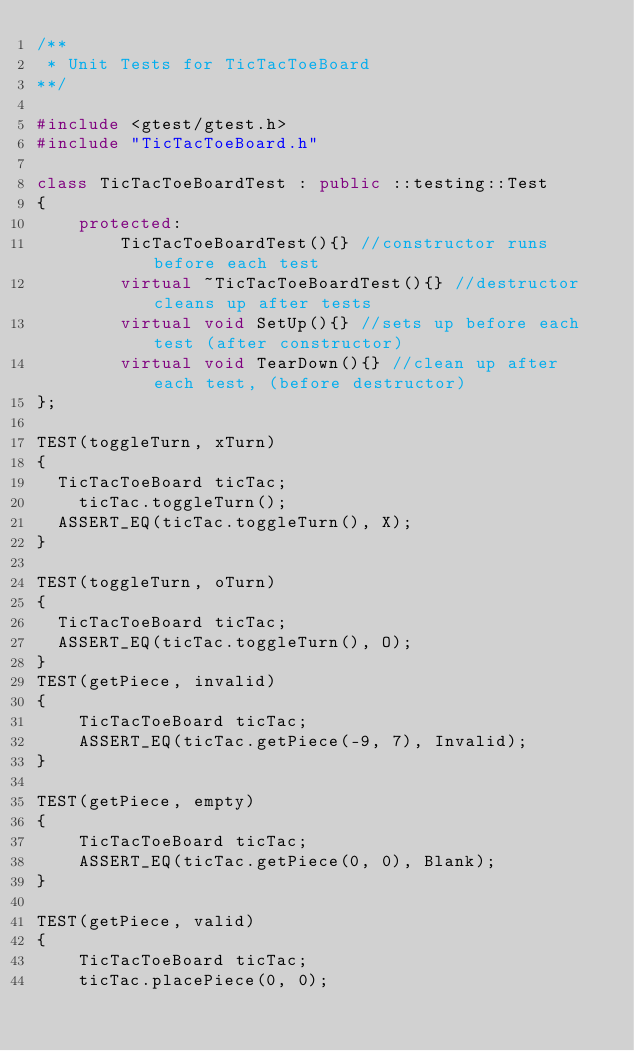<code> <loc_0><loc_0><loc_500><loc_500><_C++_>/**
 * Unit Tests for TicTacToeBoard
**/

#include <gtest/gtest.h>
#include "TicTacToeBoard.h"

class TicTacToeBoardTest : public ::testing::Test
{
	protected:
		TicTacToeBoardTest(){} //constructor runs before each test
		virtual ~TicTacToeBoardTest(){} //destructor cleans up after tests
		virtual void SetUp(){} //sets up before each test (after constructor)
		virtual void TearDown(){} //clean up after each test, (before destructor)
};

TEST(toggleTurn, xTurn)
{
  TicTacToeBoard ticTac;
	ticTac.toggleTurn();
  ASSERT_EQ(ticTac.toggleTurn(), X);
}

TEST(toggleTurn, oTurn)
{
  TicTacToeBoard ticTac;
  ASSERT_EQ(ticTac.toggleTurn(), O);
}
TEST(getPiece, invalid)
{
	TicTacToeBoard ticTac;
	ASSERT_EQ(ticTac.getPiece(-9, 7), Invalid);
}

TEST(getPiece, empty)
{
	TicTacToeBoard ticTac;
	ASSERT_EQ(ticTac.getPiece(0, 0), Blank);
}

TEST(getPiece, valid)
{
	TicTacToeBoard ticTac;
	ticTac.placePiece(0, 0);</code> 